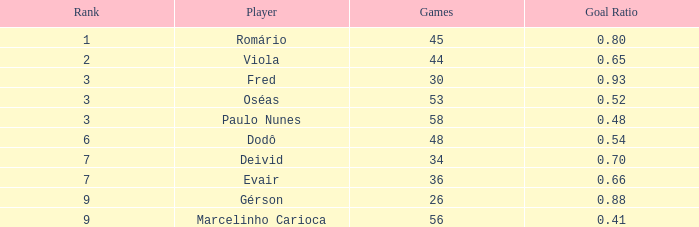How many goal ratios have rank of 2 with more than 44 games? 0.0. 